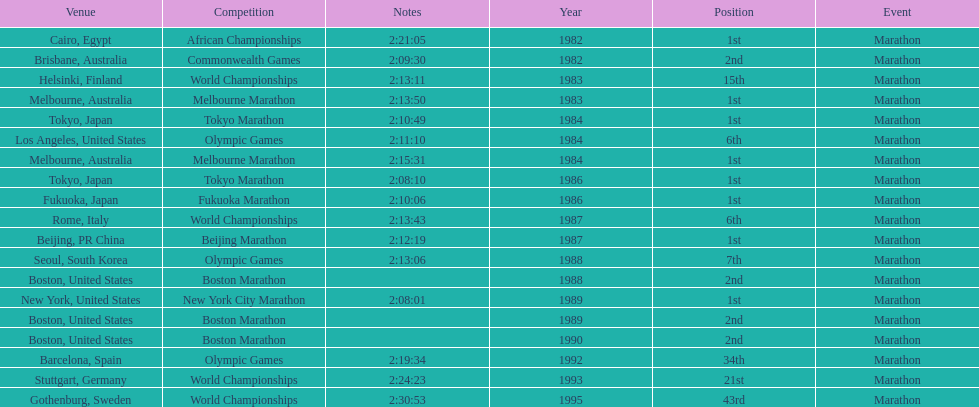What was the first marathon juma ikangaa won? 1982 African Championships. 